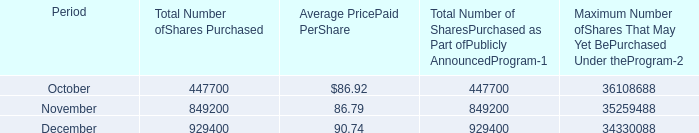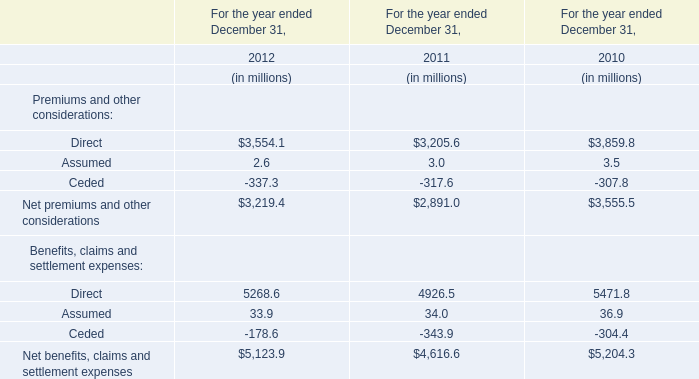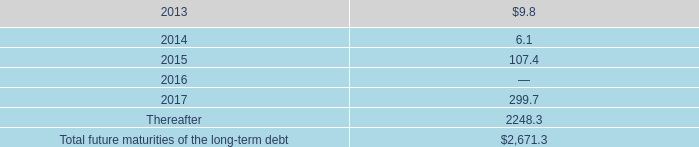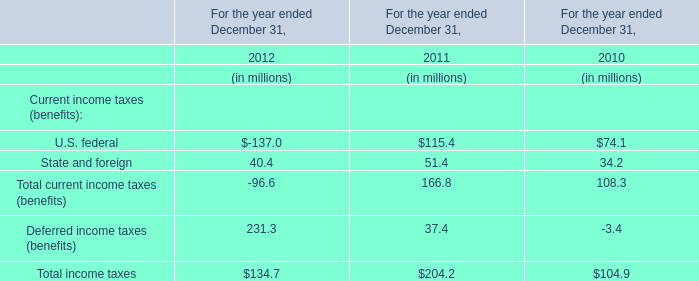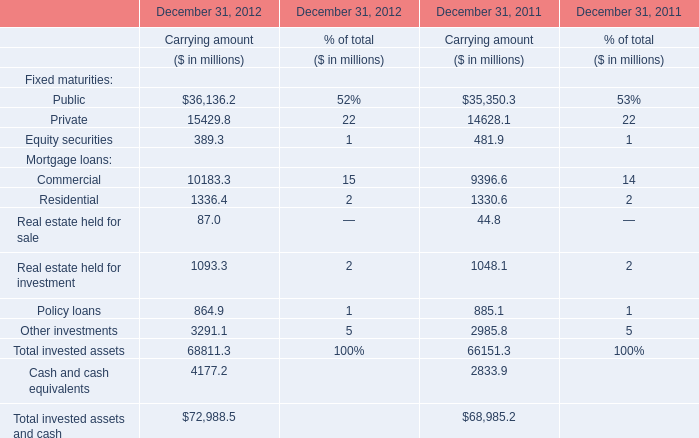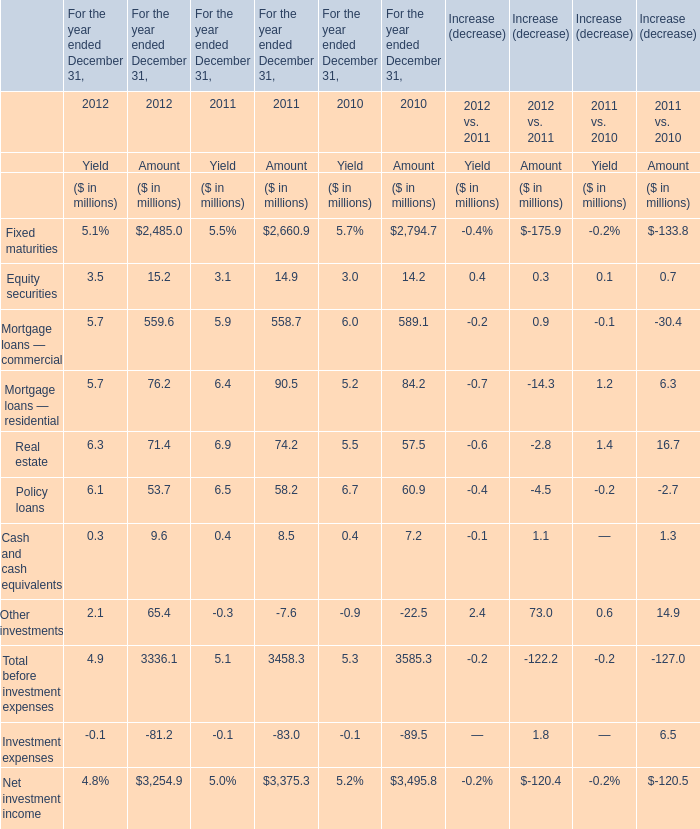Which year is Mortgage loans — residential the most? 
Answer: 2011. 